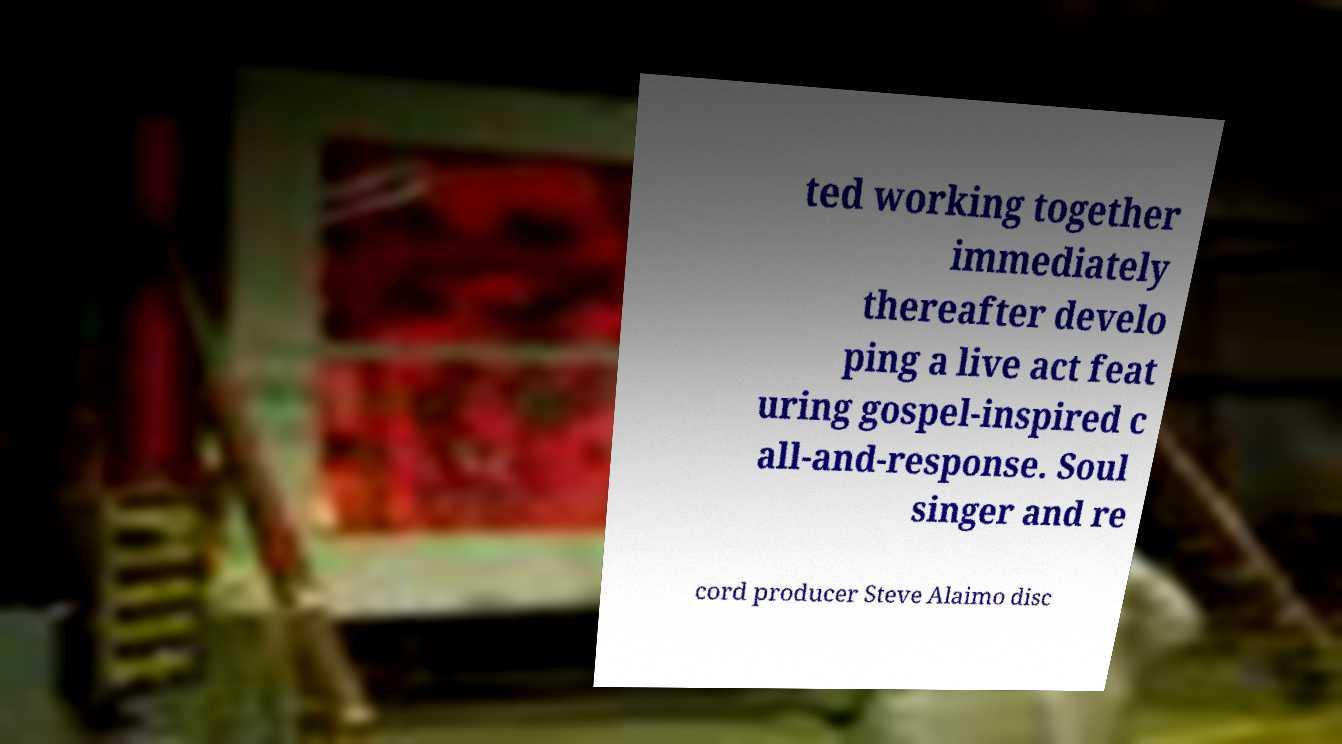Could you assist in decoding the text presented in this image and type it out clearly? ted working together immediately thereafter develo ping a live act feat uring gospel-inspired c all-and-response. Soul singer and re cord producer Steve Alaimo disc 